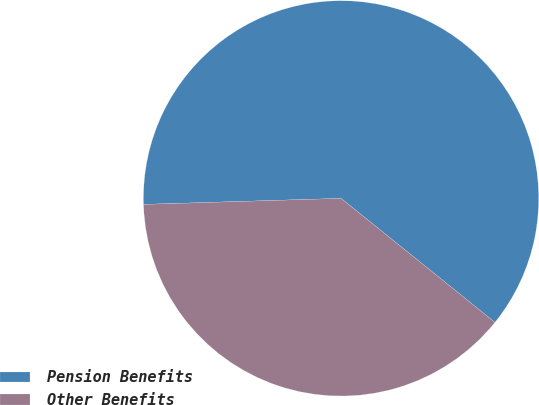Convert chart. <chart><loc_0><loc_0><loc_500><loc_500><pie_chart><fcel>Pension Benefits<fcel>Other Benefits<nl><fcel>61.28%<fcel>38.72%<nl></chart> 